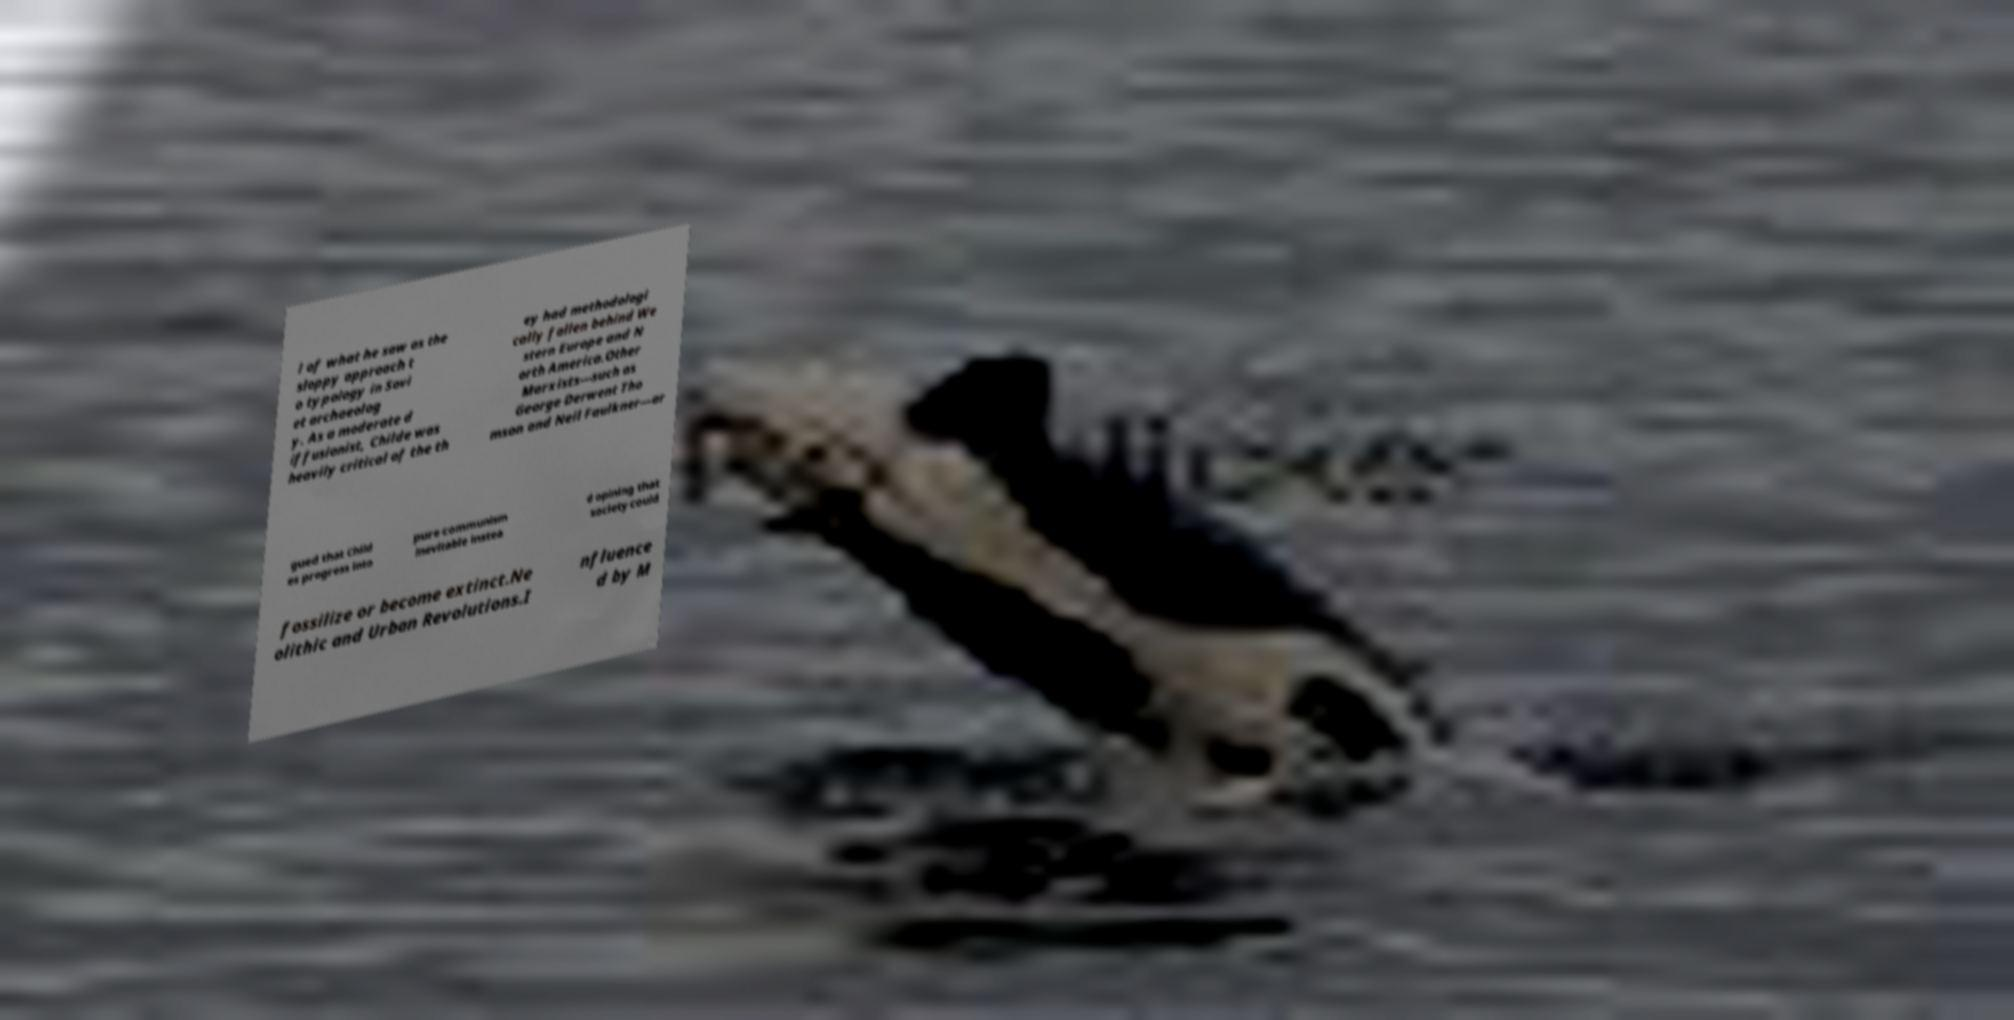Can you accurately transcribe the text from the provided image for me? l of what he saw as the sloppy approach t o typology in Sovi et archaeolog y. As a moderate d iffusionist, Childe was heavily critical of the th ey had methodologi cally fallen behind We stern Europe and N orth America.Other Marxists—such as George Derwent Tho mson and Neil Faulkner—ar gued that Child es progress into pure communism inevitable instea d opining that society could fossilize or become extinct.Ne olithic and Urban Revolutions.I nfluence d by M 